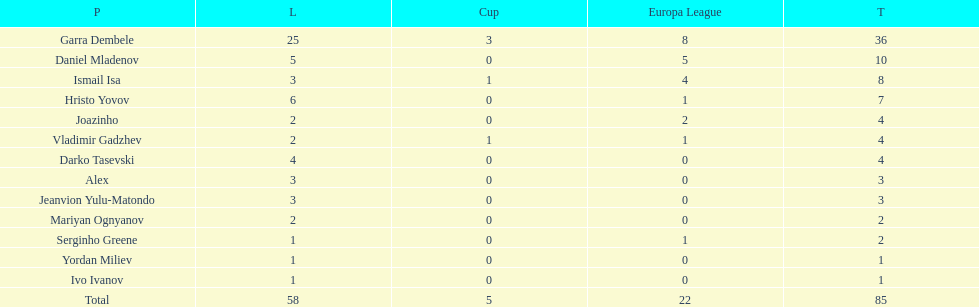How many of the players did not score any goals in the cup? 10. 